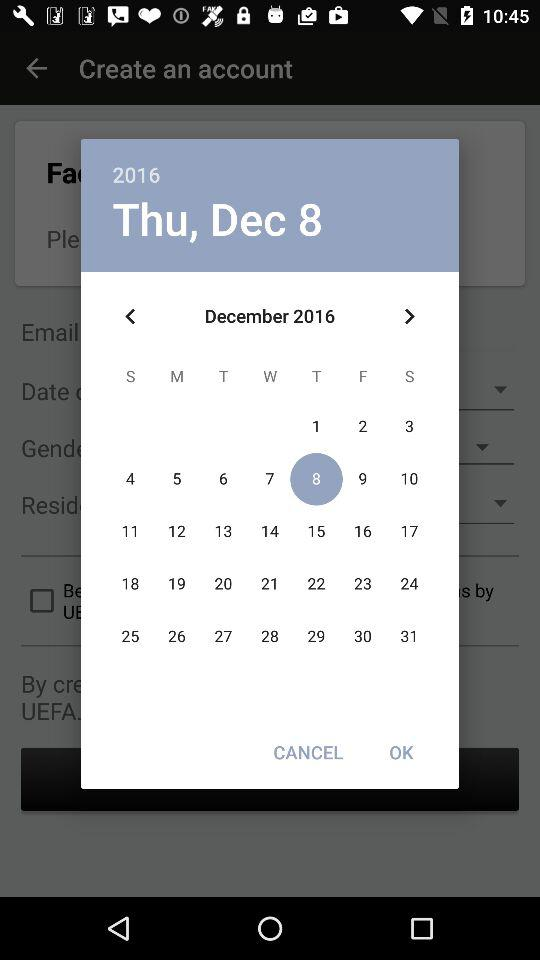What is the day of the selected date? The day of the selected date is Thursday. 